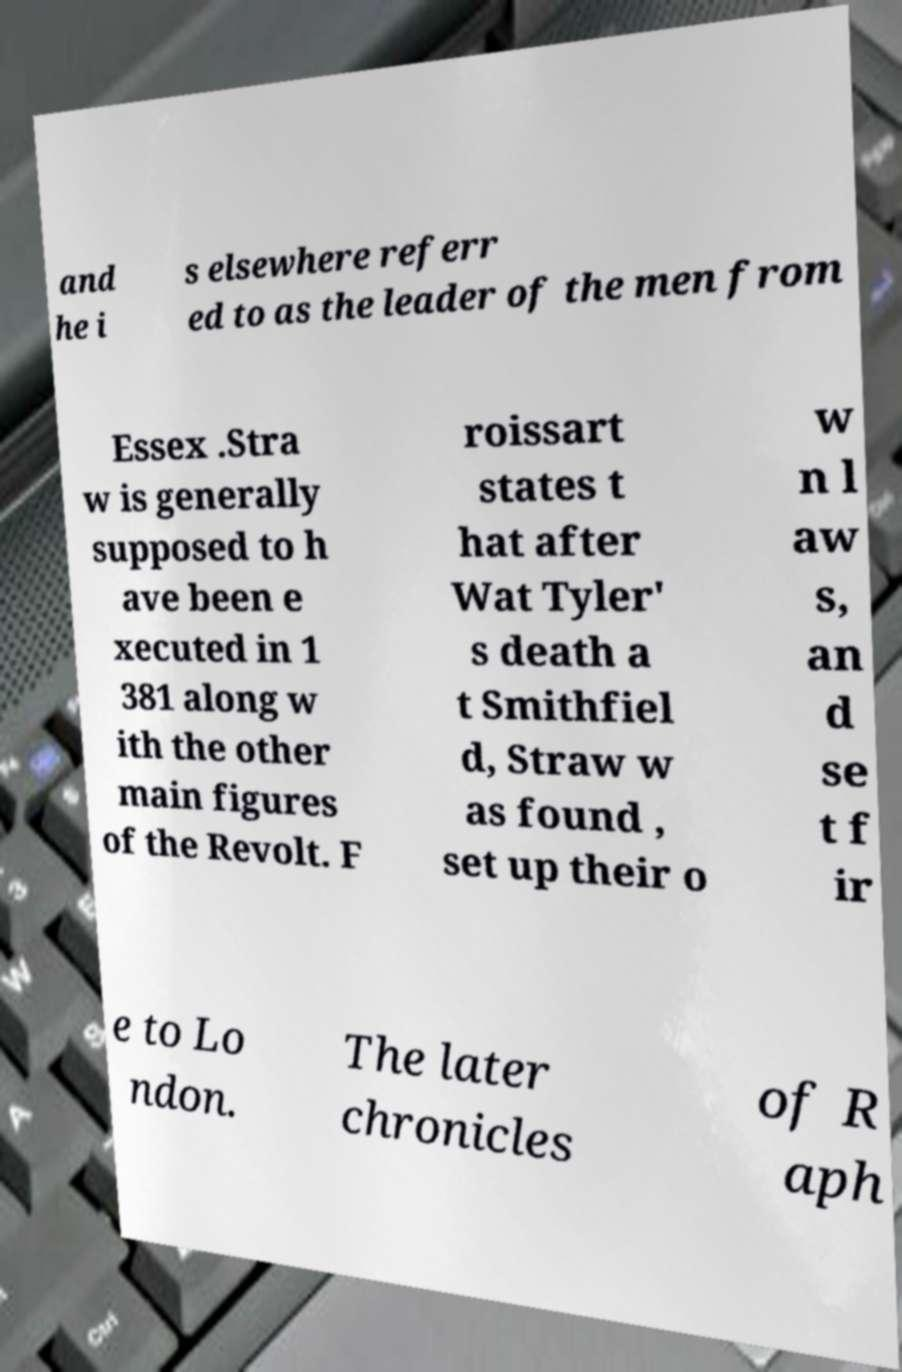What messages or text are displayed in this image? I need them in a readable, typed format. and he i s elsewhere referr ed to as the leader of the men from Essex .Stra w is generally supposed to h ave been e xecuted in 1 381 along w ith the other main figures of the Revolt. F roissart states t hat after Wat Tyler' s death a t Smithfiel d, Straw w as found , set up their o w n l aw s, an d se t f ir e to Lo ndon. The later chronicles of R aph 